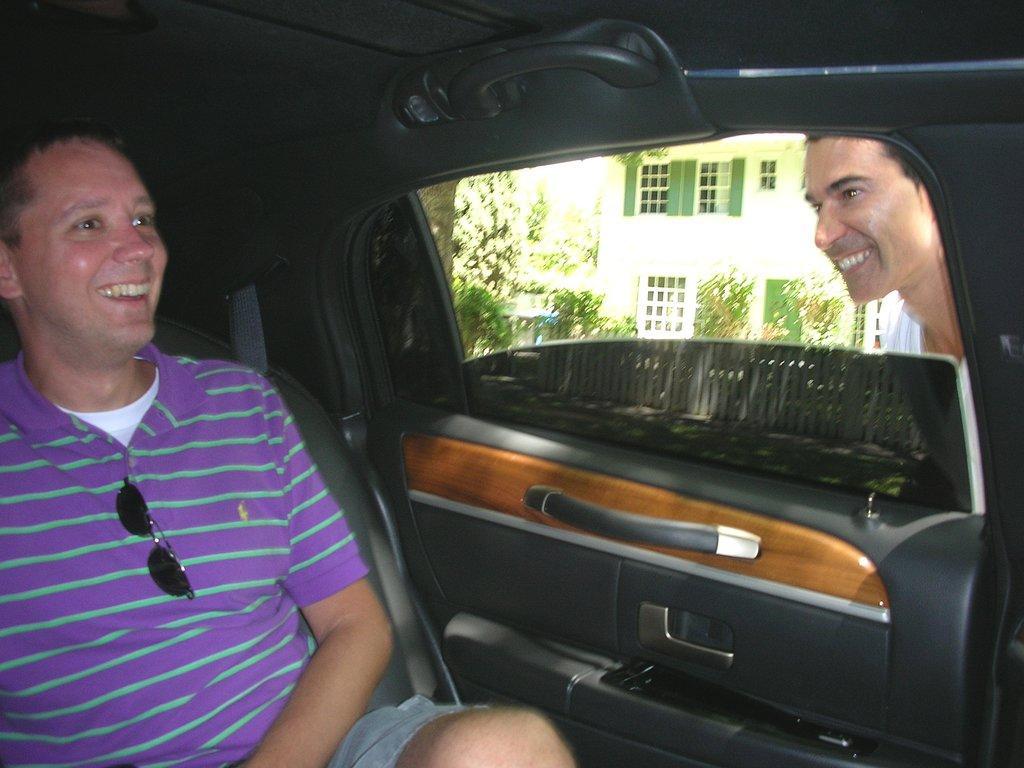Could you give a brief overview of what you see in this image? In this image we can see two persons one is standing outside of the car and another one is sitting in the car and the both are laughing in the background we can find a building and a tree. 